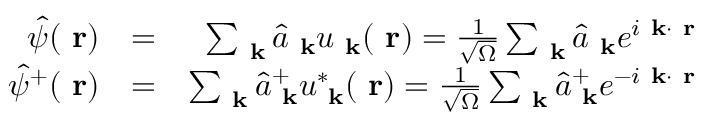Convert formula to latex. <formula><loc_0><loc_0><loc_500><loc_500>\begin{array} { r l r } { \hat { \psi } ( r ) } & { = } & { \sum _ { k } \hat { a } _ { k } u _ { k } ( r ) = \frac { 1 } { \sqrt { \Omega } } \sum _ { k } \hat { a } _ { k } e ^ { i k \cdot r } } \\ { \hat { \psi } ^ { + } ( r ) } & { = } & { \sum _ { k } \hat { a } _ { k } ^ { + } u _ { k } ^ { * } ( r ) = \frac { 1 } { \sqrt { \Omega } } \sum _ { k } \hat { a } _ { k } ^ { + } e ^ { - i k \cdot r } } \end{array}</formula> 